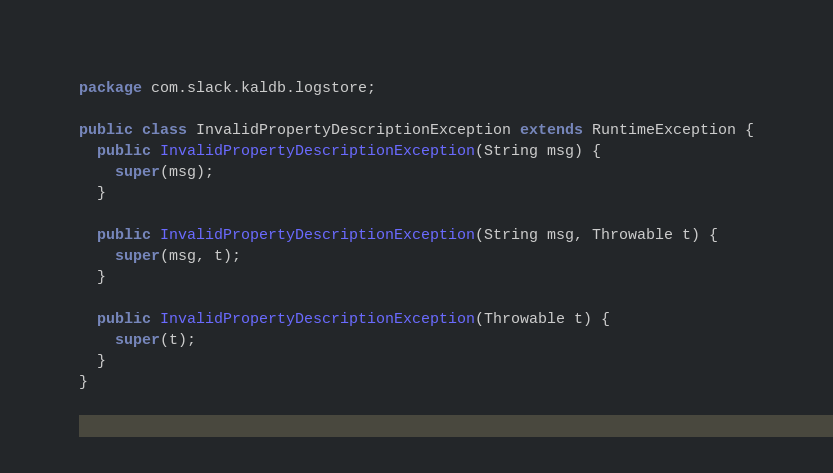Convert code to text. <code><loc_0><loc_0><loc_500><loc_500><_Java_>package com.slack.kaldb.logstore;

public class InvalidPropertyDescriptionException extends RuntimeException {
  public InvalidPropertyDescriptionException(String msg) {
    super(msg);
  }

  public InvalidPropertyDescriptionException(String msg, Throwable t) {
    super(msg, t);
  }

  public InvalidPropertyDescriptionException(Throwable t) {
    super(t);
  }
}
</code> 